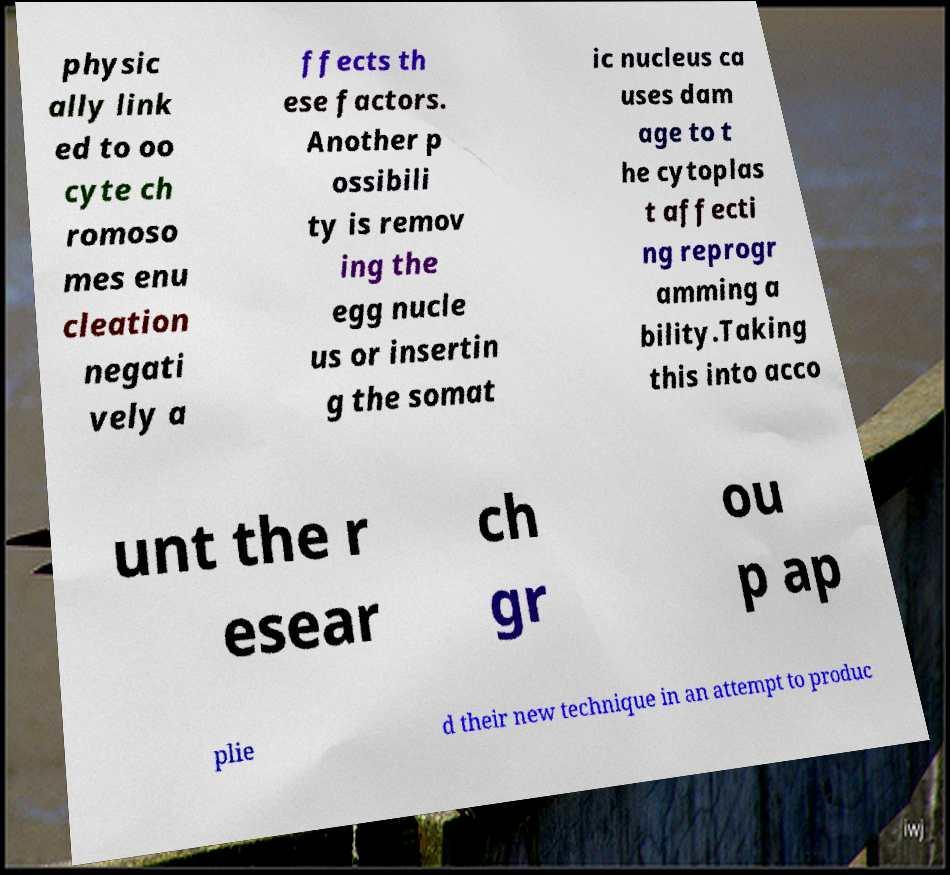Could you assist in decoding the text presented in this image and type it out clearly? physic ally link ed to oo cyte ch romoso mes enu cleation negati vely a ffects th ese factors. Another p ossibili ty is remov ing the egg nucle us or insertin g the somat ic nucleus ca uses dam age to t he cytoplas t affecti ng reprogr amming a bility.Taking this into acco unt the r esear ch gr ou p ap plie d their new technique in an attempt to produc 